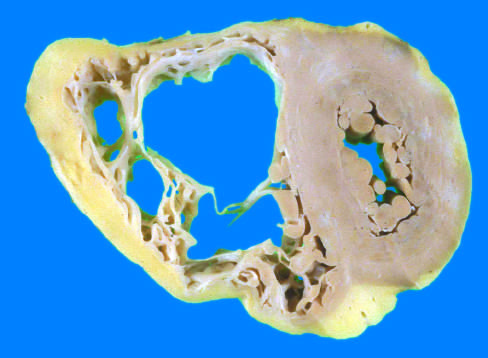what is the right ventricle markedly dilated with?
Answer the question using a single word or phrase. Focal 